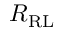Convert formula to latex. <formula><loc_0><loc_0><loc_500><loc_500>R _ { R L }</formula> 